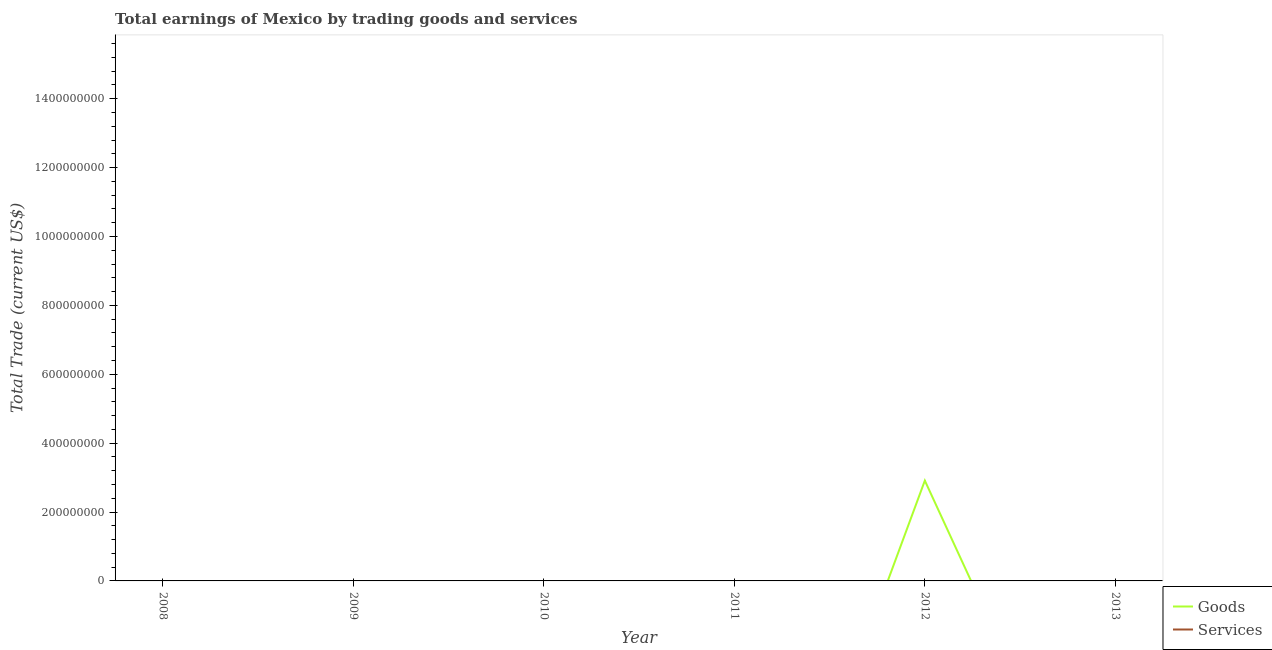How many different coloured lines are there?
Keep it short and to the point. 1. Does the line corresponding to amount earned by trading goods intersect with the line corresponding to amount earned by trading services?
Provide a succinct answer. No. Is the number of lines equal to the number of legend labels?
Your response must be concise. No. What is the amount earned by trading services in 2010?
Offer a very short reply. 0. Across all years, what is the maximum amount earned by trading goods?
Give a very brief answer. 2.91e+08. In which year was the amount earned by trading goods maximum?
Offer a very short reply. 2012. What is the difference between the amount earned by trading services in 2008 and the amount earned by trading goods in 2010?
Provide a succinct answer. 0. What is the average amount earned by trading services per year?
Give a very brief answer. 0. What is the difference between the highest and the lowest amount earned by trading goods?
Ensure brevity in your answer.  2.91e+08. In how many years, is the amount earned by trading services greater than the average amount earned by trading services taken over all years?
Provide a succinct answer. 0. Is the amount earned by trading goods strictly greater than the amount earned by trading services over the years?
Give a very brief answer. Yes. Is the amount earned by trading goods strictly less than the amount earned by trading services over the years?
Provide a succinct answer. No. How many lines are there?
Your answer should be compact. 1. How many years are there in the graph?
Offer a terse response. 6. Does the graph contain any zero values?
Give a very brief answer. Yes. Does the graph contain grids?
Provide a short and direct response. No. How are the legend labels stacked?
Your response must be concise. Vertical. What is the title of the graph?
Give a very brief answer. Total earnings of Mexico by trading goods and services. What is the label or title of the X-axis?
Provide a succinct answer. Year. What is the label or title of the Y-axis?
Ensure brevity in your answer.  Total Trade (current US$). What is the Total Trade (current US$) of Services in 2009?
Your answer should be compact. 0. What is the Total Trade (current US$) in Goods in 2010?
Keep it short and to the point. 0. What is the Total Trade (current US$) of Services in 2010?
Your response must be concise. 0. What is the Total Trade (current US$) in Goods in 2011?
Ensure brevity in your answer.  0. What is the Total Trade (current US$) in Goods in 2012?
Provide a succinct answer. 2.91e+08. What is the Total Trade (current US$) of Services in 2012?
Keep it short and to the point. 0. Across all years, what is the maximum Total Trade (current US$) of Goods?
Offer a very short reply. 2.91e+08. Across all years, what is the minimum Total Trade (current US$) in Goods?
Offer a terse response. 0. What is the total Total Trade (current US$) of Goods in the graph?
Make the answer very short. 2.91e+08. What is the total Total Trade (current US$) of Services in the graph?
Keep it short and to the point. 0. What is the average Total Trade (current US$) in Goods per year?
Give a very brief answer. 4.85e+07. What is the difference between the highest and the lowest Total Trade (current US$) in Goods?
Provide a short and direct response. 2.91e+08. 